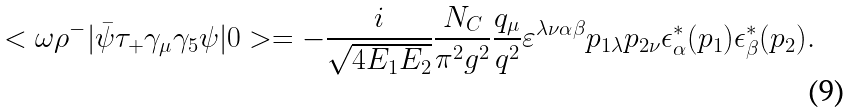Convert formula to latex. <formula><loc_0><loc_0><loc_500><loc_500>< \omega \rho ^ { - } | \bar { \psi } \tau _ { + } \gamma _ { \mu } \gamma _ { 5 } \psi | 0 > = - \frac { i } { \sqrt { 4 E _ { 1 } E _ { 2 } } } \frac { N _ { C } } { \pi ^ { 2 } g ^ { 2 } } \frac { q _ { \mu } } { q ^ { 2 } } \varepsilon ^ { \lambda \nu \alpha \beta } p _ { 1 \lambda } p _ { 2 \nu } \epsilon ^ { * } _ { \alpha } ( p _ { 1 } ) \epsilon ^ { * } _ { \beta } ( p _ { 2 } ) .</formula> 